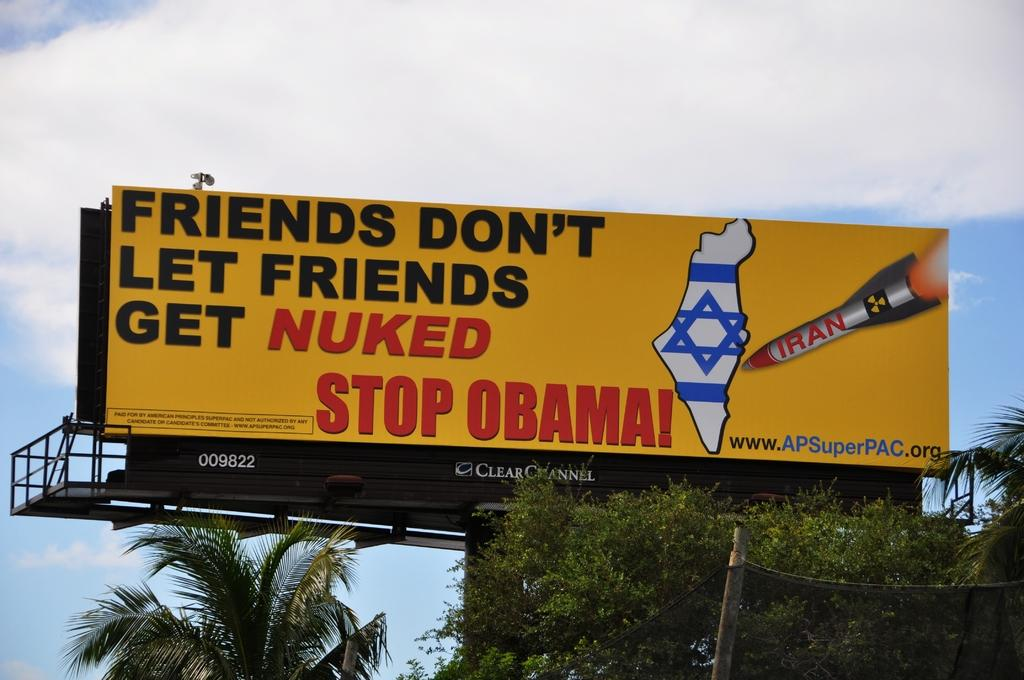<image>
Present a compact description of the photo's key features. The billboard wants to stop Obama because friends don't let friends get nuked. 